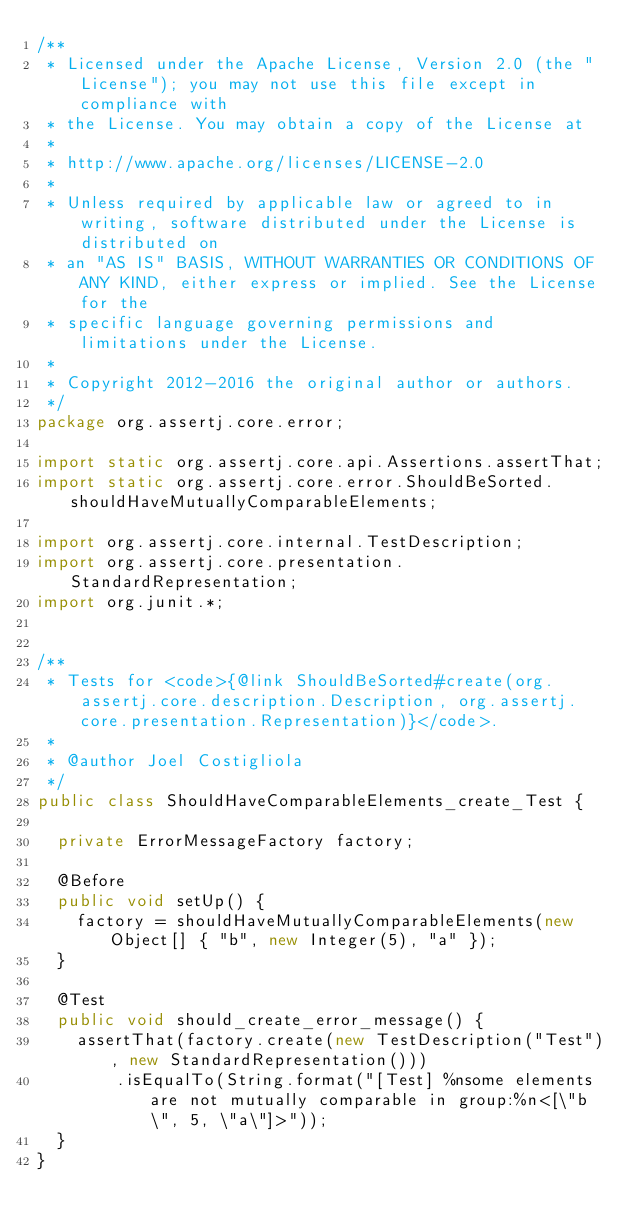<code> <loc_0><loc_0><loc_500><loc_500><_Java_>/**
 * Licensed under the Apache License, Version 2.0 (the "License"); you may not use this file except in compliance with
 * the License. You may obtain a copy of the License at
 *
 * http://www.apache.org/licenses/LICENSE-2.0
 *
 * Unless required by applicable law or agreed to in writing, software distributed under the License is distributed on
 * an "AS IS" BASIS, WITHOUT WARRANTIES OR CONDITIONS OF ANY KIND, either express or implied. See the License for the
 * specific language governing permissions and limitations under the License.
 *
 * Copyright 2012-2016 the original author or authors.
 */
package org.assertj.core.error;

import static org.assertj.core.api.Assertions.assertThat;
import static org.assertj.core.error.ShouldBeSorted.shouldHaveMutuallyComparableElements;

import org.assertj.core.internal.TestDescription;
import org.assertj.core.presentation.StandardRepresentation;
import org.junit.*;


/**
 * Tests for <code>{@link ShouldBeSorted#create(org.assertj.core.description.Description, org.assertj.core.presentation.Representation)}</code>.
 * 
 * @author Joel Costigliola
 */
public class ShouldHaveComparableElements_create_Test {

  private ErrorMessageFactory factory;

  @Before
  public void setUp() {
    factory = shouldHaveMutuallyComparableElements(new Object[] { "b", new Integer(5), "a" });
  }

  @Test
  public void should_create_error_message() {
    assertThat(factory.create(new TestDescription("Test"), new StandardRepresentation()))
        .isEqualTo(String.format("[Test] %nsome elements are not mutually comparable in group:%n<[\"b\", 5, \"a\"]>"));
  }
}
</code> 